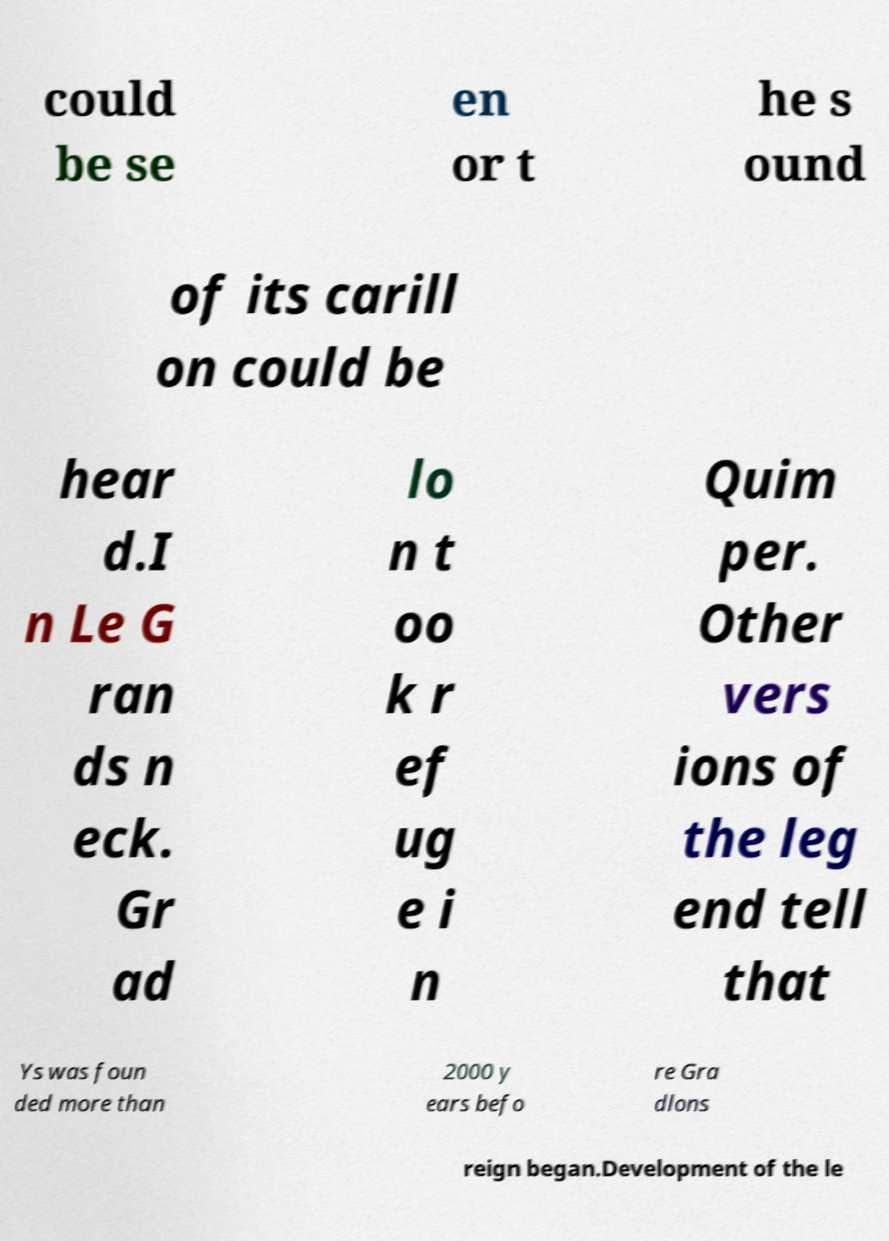There's text embedded in this image that I need extracted. Can you transcribe it verbatim? could be se en or t he s ound of its carill on could be hear d.I n Le G ran ds n eck. Gr ad lo n t oo k r ef ug e i n Quim per. Other vers ions of the leg end tell that Ys was foun ded more than 2000 y ears befo re Gra dlons reign began.Development of the le 